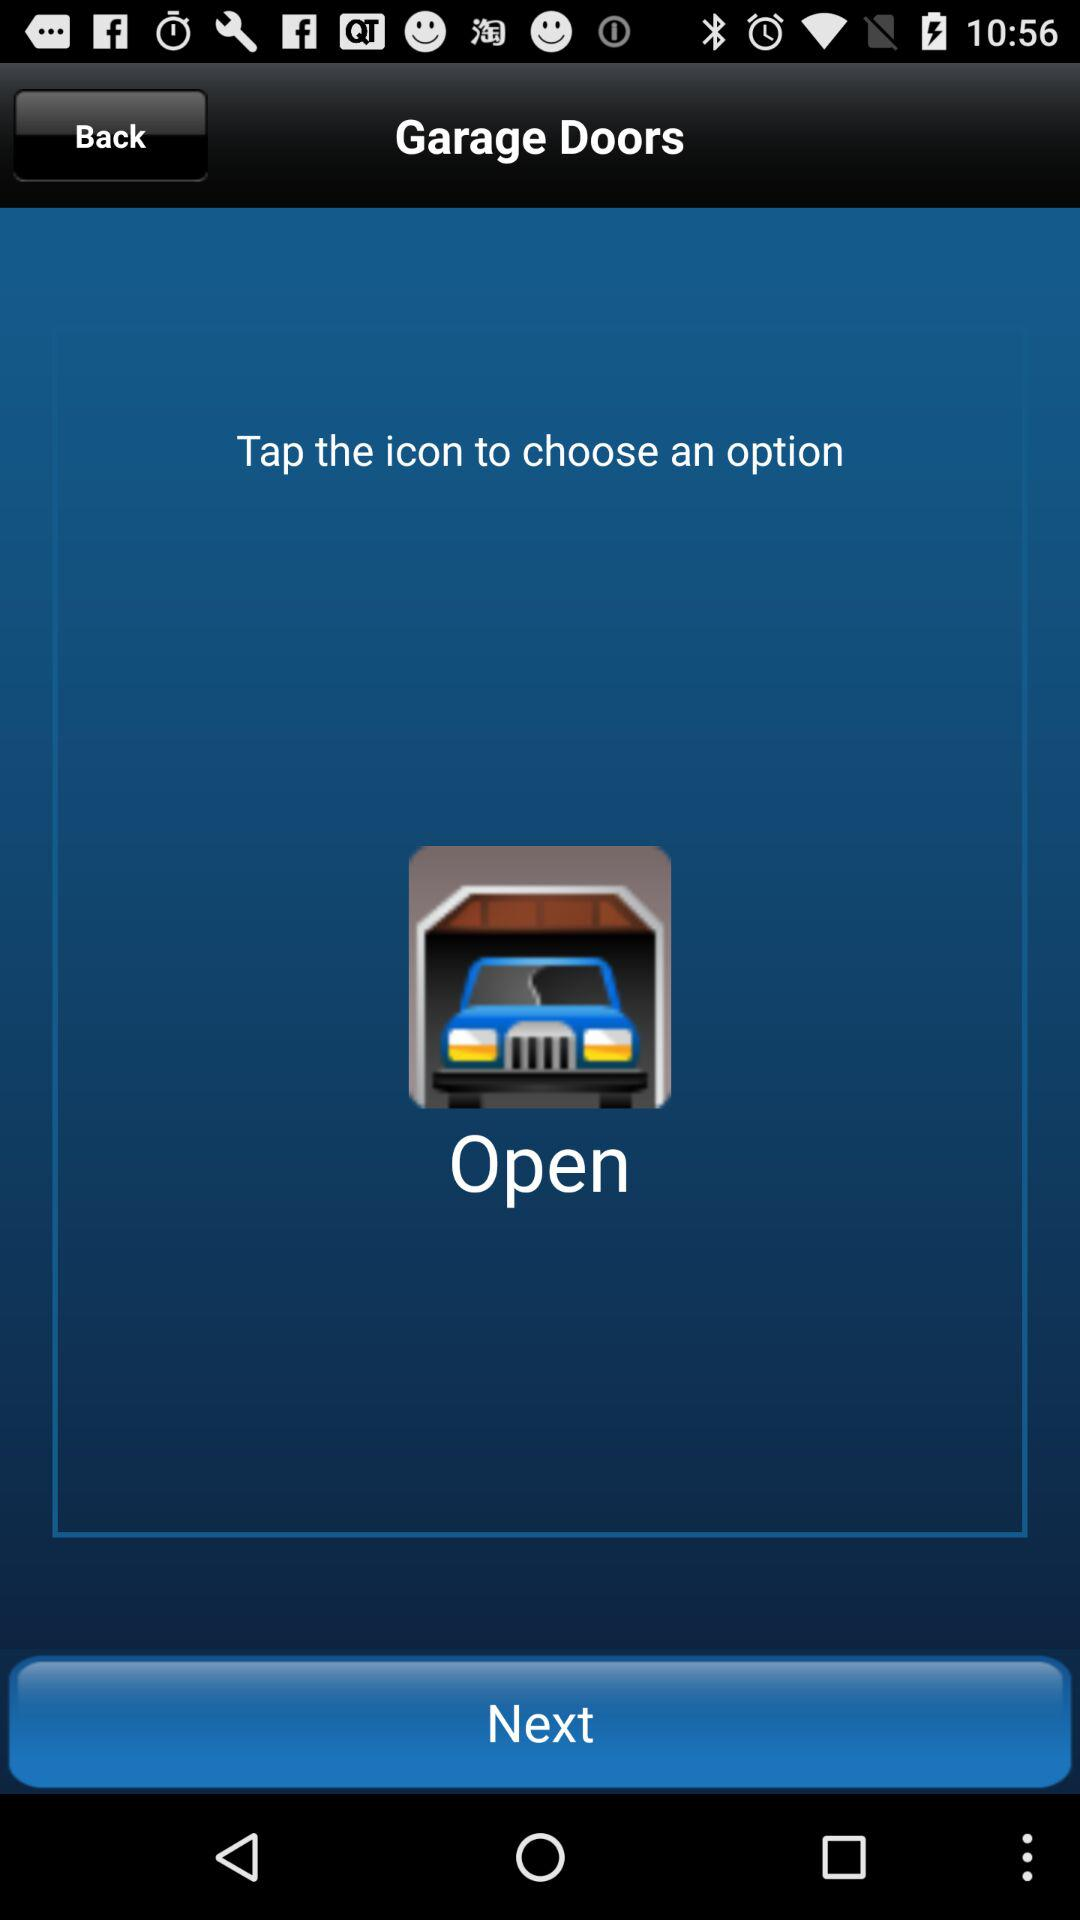What is the app name? The app name is "Garage Doors". 